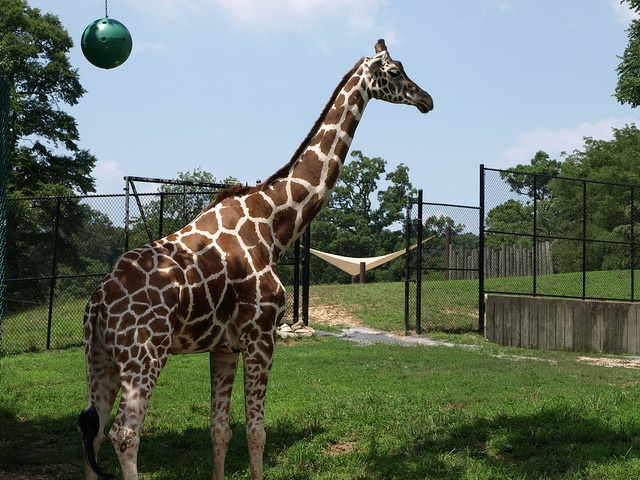Describe the objects in this image and their specific colors. I can see a giraffe in darkgreen, black, gray, and maroon tones in this image. 